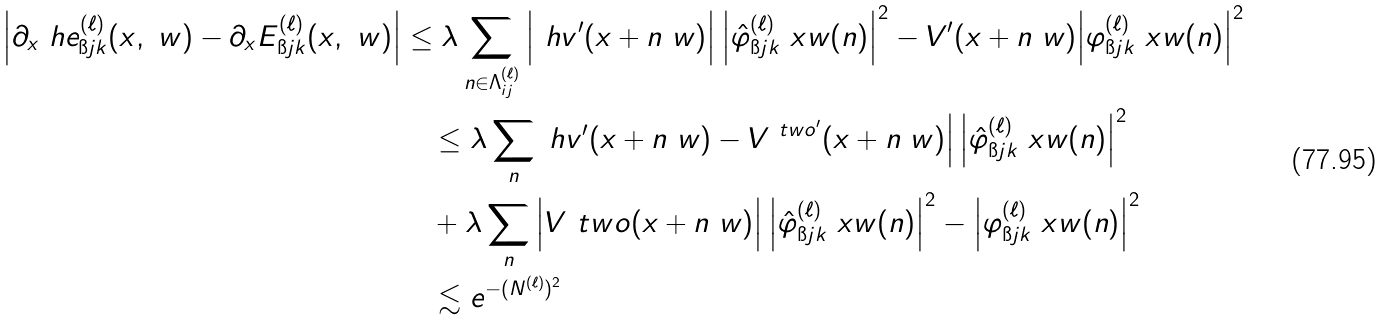Convert formula to latex. <formula><loc_0><loc_0><loc_500><loc_500>\Big | \partial _ { x } \ h e _ { \i j k } ^ { ( \ell ) } ( x , \ w ) - \partial _ { x } E _ { \i j k } ^ { ( \ell ) } ( x , \ w ) \Big | & \leq \lambda \sum _ { n \in \Lambda _ { i j } ^ { ( \ell ) } } \Big | \ h v ^ { \prime } ( x + n \ w ) \Big | \, \Big | \hat { \varphi } _ { \i j k } ^ { ( \ell ) } \ x w ( n ) \Big | ^ { 2 } - V ^ { \prime } ( x + n \ w ) \Big | \varphi _ { \i j k } ^ { ( \ell ) } \ x w ( n ) \Big | ^ { 2 } \\ & \quad \leq \lambda \sum _ { n } \ h v ^ { \prime } ( x + n \ w ) - V ^ { \ t w o ^ { \prime } } ( x + n \ w ) \Big | \, \Big | \hat { \varphi } _ { \i j k } ^ { ( \ell ) } \ x w ( n ) \Big | ^ { 2 } \\ & \quad + \lambda \sum _ { n } \Big | V ^ { \ } t w o ( x + n \ w ) \Big | \, \Big | \hat { \varphi } _ { \i j k } ^ { ( \ell ) } \ x w ( n ) \Big | ^ { 2 } - \Big | \varphi _ { \i j k } ^ { ( \ell ) } \ x w ( n ) \Big | ^ { 2 } \\ & \quad \lesssim e ^ { - ( N ^ { ( \ell ) } ) ^ { 2 } }</formula> 